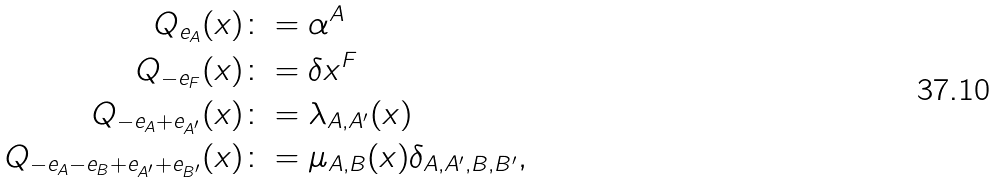<formula> <loc_0><loc_0><loc_500><loc_500>Q _ { e _ { A } } ( x ) & \colon = \alpha ^ { A } \\ Q _ { - e _ { F } } ( x ) & \colon = \delta x ^ { F } \\ Q _ { - e _ { A } + e _ { A ^ { \prime } } } ( x ) & \colon = \lambda _ { A , A ^ { \prime } } ( x ) \\ Q _ { - e _ { A } - e _ { B } + e _ { A ^ { \prime } } + e _ { B ^ { \prime } } } ( x ) & \colon = \mu _ { A , B } ( x ) \delta _ { A , A ^ { \prime } , B , B ^ { \prime } } ,</formula> 